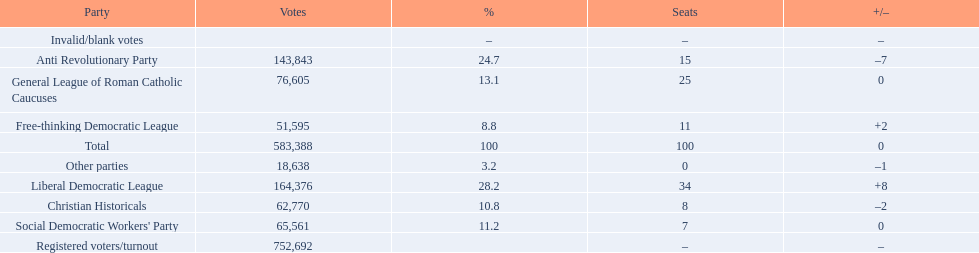After the election, how many seats did the liberal democratic league win? 34. 